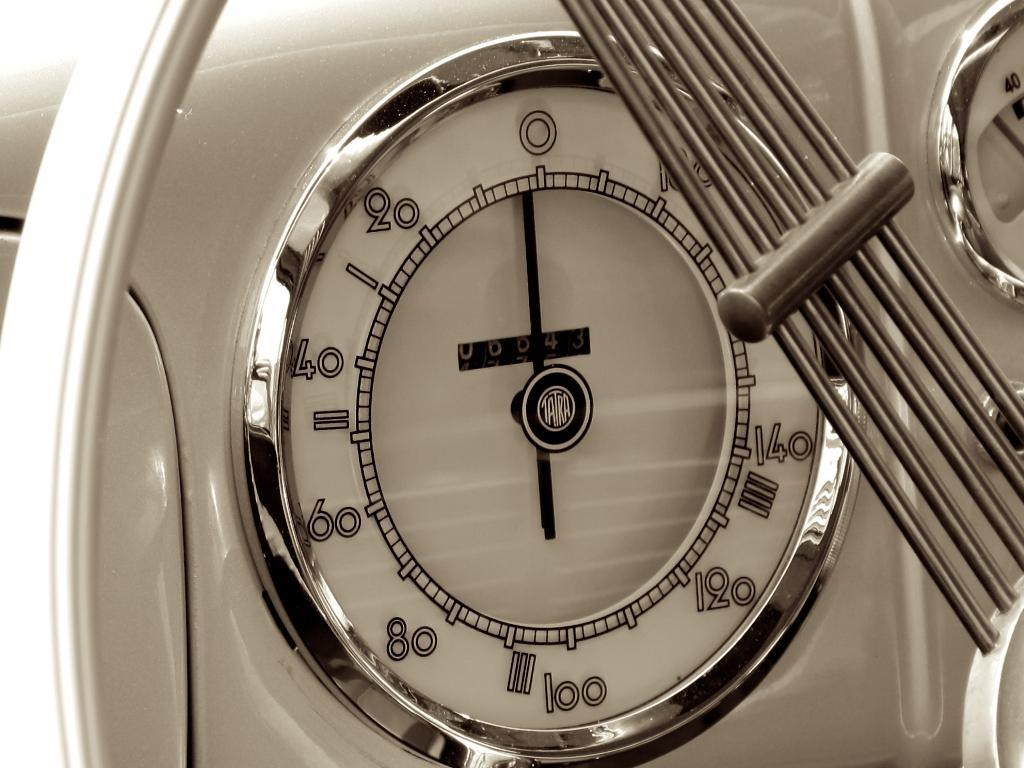What type of devices are visible in the image? There are speed meters in the image. What material are the rods made of in the image? The rods in the image are made of steel. What color stocking is the person wearing in the image? There is no person or stocking present in the image; it only features speed meters and steel rods. What type of flooring can be seen in the image? There is no flooring visible in the image, as it only shows speed meters and steel rods. 